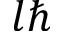<formula> <loc_0><loc_0><loc_500><loc_500>l \hbar</formula> 